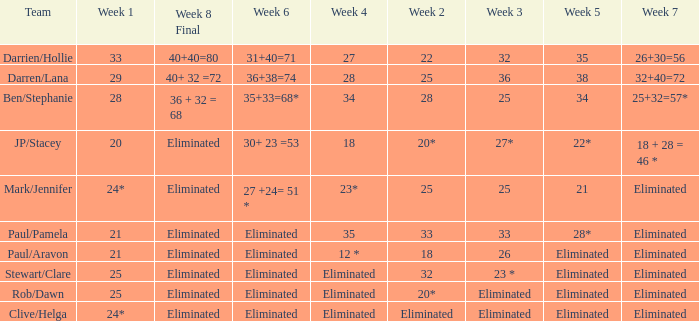Name the week 3 of 36 29.0. Parse the full table. {'header': ['Team', 'Week 1', 'Week 8 Final', 'Week 6', 'Week 4', 'Week 2', 'Week 3', 'Week 5', 'Week 7'], 'rows': [['Darrien/Hollie', '33', '40+40=80', '31+40=71', '27', '22', '32', '35', '26+30=56'], ['Darren/Lana', '29', '40+ 32 =72', '36+38=74', '28', '25', '36', '38', '32+40=72'], ['Ben/Stephanie', '28', '36 + 32 = 68', '35+33=68*', '34', '28', '25', '34', '25+32=57*'], ['JP/Stacey', '20', 'Eliminated', '30+ 23 =53', '18', '20*', '27*', '22*', '18 + 28 = 46 *'], ['Mark/Jennifer', '24*', 'Eliminated', '27 +24= 51 *', '23*', '25', '25', '21', 'Eliminated'], ['Paul/Pamela', '21', 'Eliminated', 'Eliminated', '35', '33', '33', '28*', 'Eliminated'], ['Paul/Aravon', '21', 'Eliminated', 'Eliminated', '12 *', '18', '26', 'Eliminated', 'Eliminated'], ['Stewart/Clare', '25', 'Eliminated', 'Eliminated', 'Eliminated', '32', '23 *', 'Eliminated', 'Eliminated'], ['Rob/Dawn', '25', 'Eliminated', 'Eliminated', 'Eliminated', '20*', 'Eliminated', 'Eliminated', 'Eliminated'], ['Clive/Helga', '24*', 'Eliminated', 'Eliminated', 'Eliminated', 'Eliminated', 'Eliminated', 'Eliminated', 'Eliminated']]} 